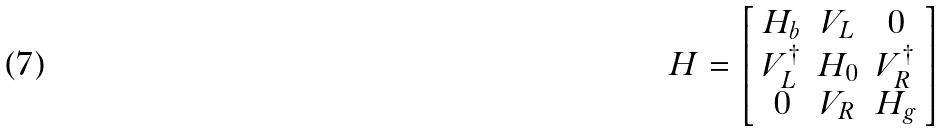<formula> <loc_0><loc_0><loc_500><loc_500>H = \left [ \begin{array} { c c c } H _ { b } & V _ { L } & 0 \\ V ^ { \dag } _ { L } & H _ { 0 } & V ^ { \dag } _ { R } \\ 0 & V _ { R } & H _ { g } \end{array} \right ]</formula> 